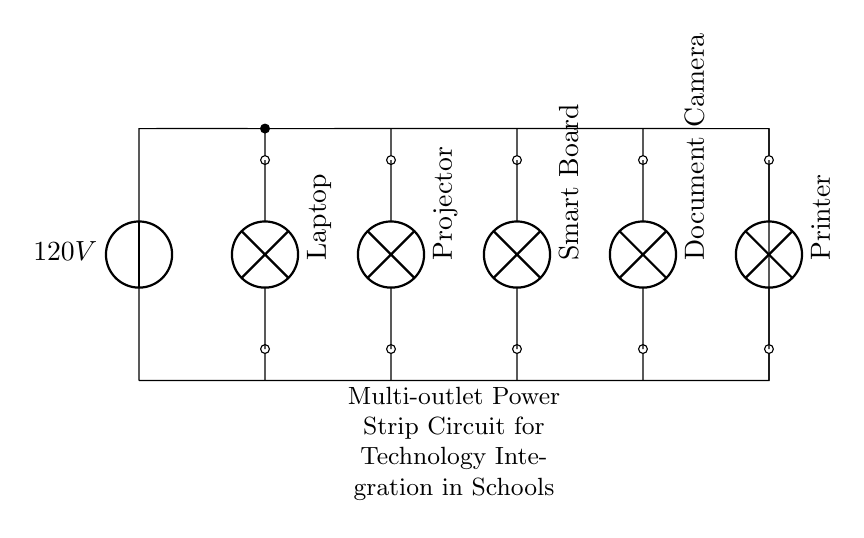What is the voltage of this circuit? The voltage is 120V, which is indicated by the voltage source on the left side of the circuit.
Answer: 120V What are the devices connected to the power strip? The devices are a laptop, projector, smart board, document camera, and printer, as labeled in the circuit diagram next to each connection point.
Answer: Laptop, projector, smart board, document camera, printer How many outlets does the power strip have? The power strip has five outlets, each represented by the short lines leading to devices in the circuit.
Answer: Five Which device is connected to the second outlet? The device connected to the second outlet is the projector, as indicated by its label on the circuit.
Answer: Projector What type of circuit is this? This is a parallel circuit, as all the devices are connected along separate paths to the same voltage source, allowing them to operate independently.
Answer: Parallel What is the function of the power strip in this circuit? The function of the power strip is to distribute the 120V voltage from the source to multiple devices simultaneously while allowing independent operation, which is crucial for technology integration in schools.
Answer: Distribute voltage What happens if one device fails in this circuit? If one device fails, it will not affect the operation of the other devices because they are arranged in parallel; each device has its own conductive path to the source.
Answer: Other devices continue to operate 